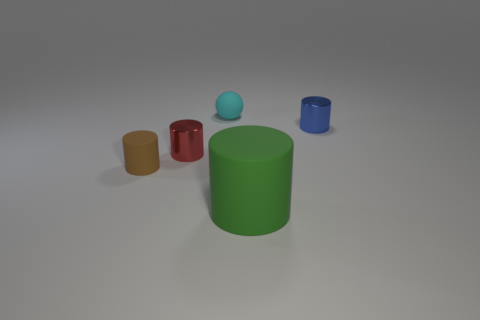If this image were part of an educational material, what could it be teaching? This image could be used in educational material to teach about concepts such as colors, shapes, sizes, light and shadow, reflections, and the properties of materials like matte and shiny surfaces. 